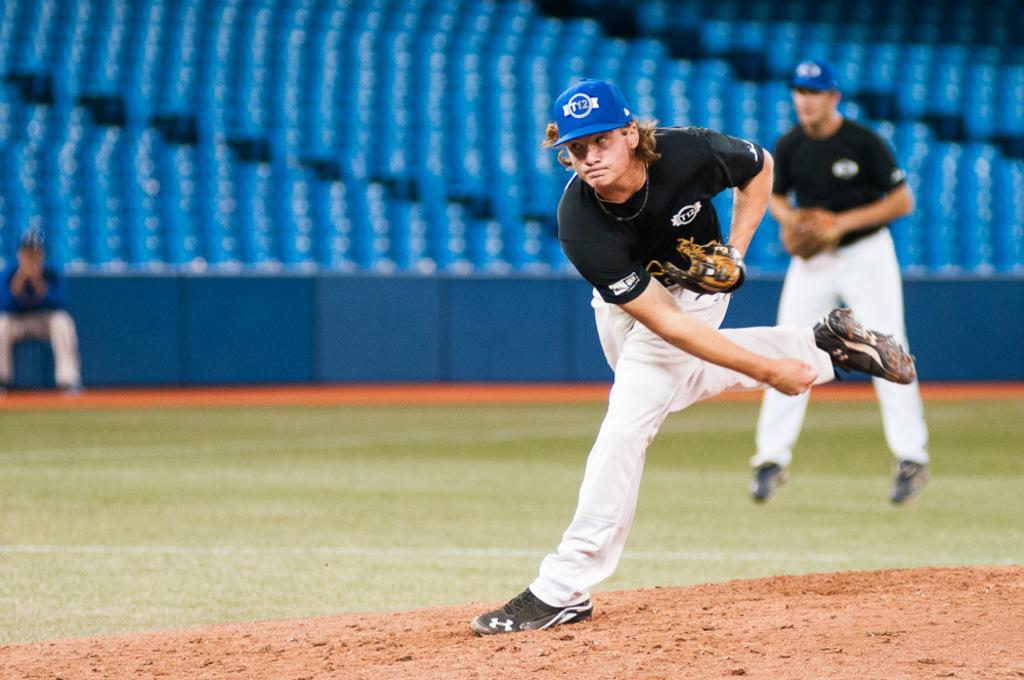How many people are in the playground in the image? There are two people in the playground in the image. What can be seen in the background of the playground? There are blue color chairs in the background. What type of trouble is the aunt causing in the playground? There is no aunt present in the image, and therefore no trouble can be observed. 